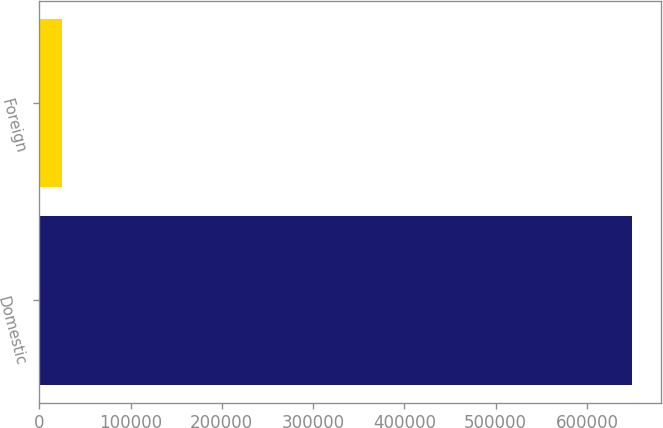Convert chart to OTSL. <chart><loc_0><loc_0><loc_500><loc_500><bar_chart><fcel>Domestic<fcel>Foreign<nl><fcel>649098<fcel>25057<nl></chart> 